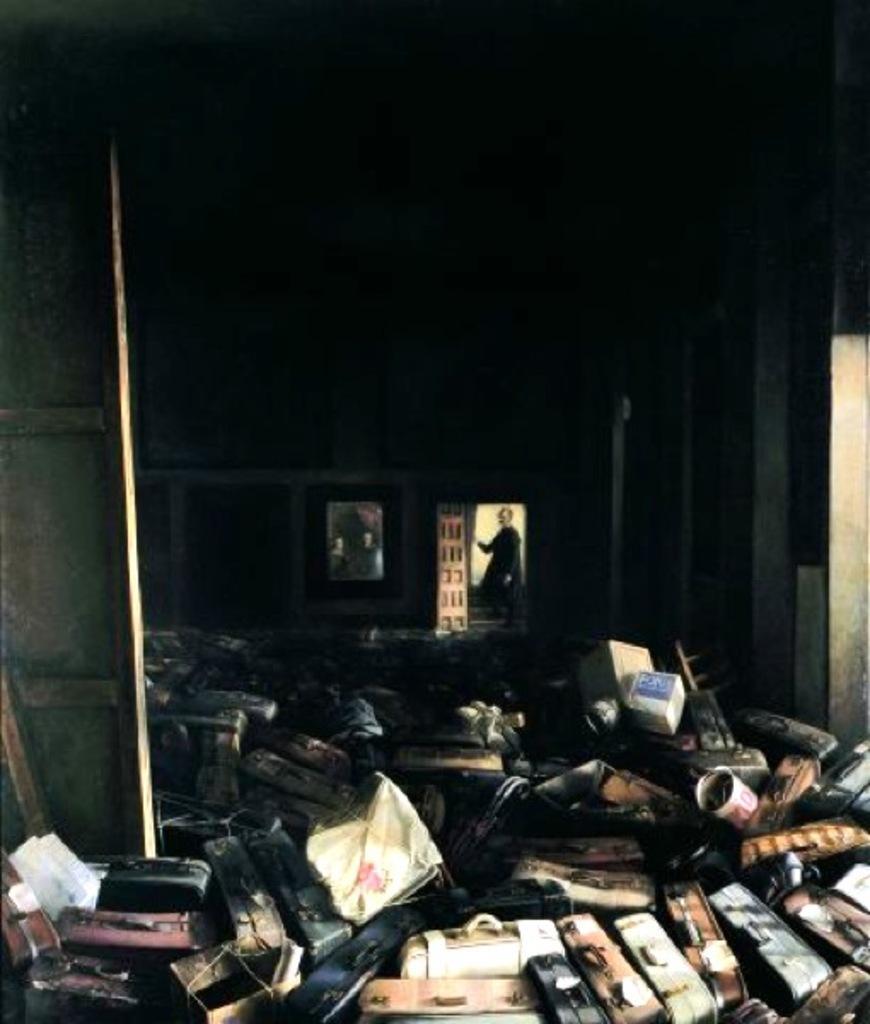Please provide a concise description of this image. In this image I can see suitcases, cartons and other objects in a room I can see the door on the left hand side of the image. I can see another door in the center of the image and a person standing. I can see a wall painting in the center just beside the door and the background is dark. 